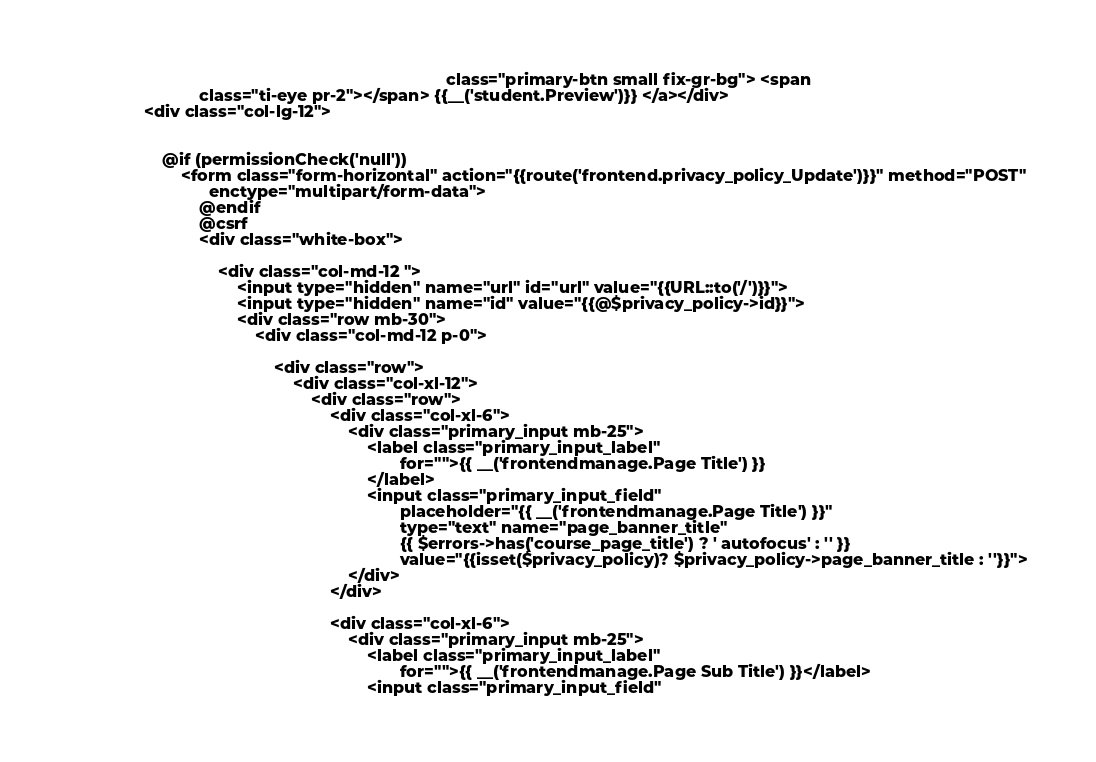<code> <loc_0><loc_0><loc_500><loc_500><_PHP_>                                                                                 class="primary-btn small fix-gr-bg"> <span
                            class="ti-eye pr-2"></span> {{__('student.Preview')}} </a></div>
                <div class="col-lg-12">


                    @if (permissionCheck('null'))
                        <form class="form-horizontal" action="{{route('frontend.privacy_policy_Update')}}" method="POST"
                              enctype="multipart/form-data">
                            @endif
                            @csrf
                            <div class="white-box">

                                <div class="col-md-12 ">
                                    <input type="hidden" name="url" id="url" value="{{URL::to('/')}}">
                                    <input type="hidden" name="id" value="{{@$privacy_policy->id}}">
                                    <div class="row mb-30">
                                        <div class="col-md-12 p-0">

                                            <div class="row">
                                                <div class="col-xl-12">
                                                    <div class="row">
                                                        <div class="col-xl-6">
                                                            <div class="primary_input mb-25">
                                                                <label class="primary_input_label"
                                                                       for="">{{ __('frontendmanage.Page Title') }}
                                                                </label>
                                                                <input class="primary_input_field"
                                                                       placeholder="{{ __('frontendmanage.Page Title') }}"
                                                                       type="text" name="page_banner_title"
                                                                       {{ $errors->has('course_page_title') ? ' autofocus' : '' }}
                                                                       value="{{isset($privacy_policy)? $privacy_policy->page_banner_title : ''}}">
                                                            </div>
                                                        </div>

                                                        <div class="col-xl-6">
                                                            <div class="primary_input mb-25">
                                                                <label class="primary_input_label"
                                                                       for="">{{ __('frontendmanage.Page Sub Title') }}</label>
                                                                <input class="primary_input_field"</code> 